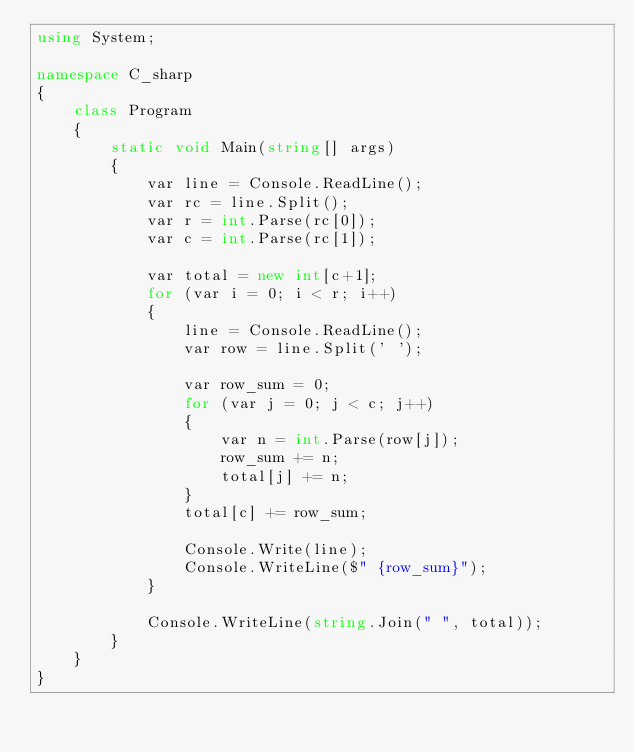Convert code to text. <code><loc_0><loc_0><loc_500><loc_500><_C#_>using System;

namespace C_sharp
{
    class Program
    {
        static void Main(string[] args)
        {
            var line = Console.ReadLine();
            var rc = line.Split();
            var r = int.Parse(rc[0]);
            var c = int.Parse(rc[1]);

            var total = new int[c+1];
            for (var i = 0; i < r; i++)
            {
                line = Console.ReadLine();
                var row = line.Split(' ');

                var row_sum = 0;
                for (var j = 0; j < c; j++)
                {
                    var n = int.Parse(row[j]);
                    row_sum += n;
                    total[j] += n;
                }
                total[c] += row_sum;

                Console.Write(line);
                Console.WriteLine($" {row_sum}");
            }

            Console.WriteLine(string.Join(" ", total));
        }
    }
}

</code> 